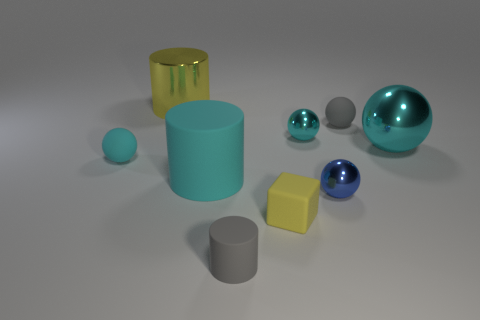Subtract all small gray matte balls. How many balls are left? 4 Subtract all cyan spheres. How many were subtracted if there are1cyan spheres left? 2 Subtract all cyan spheres. How many spheres are left? 2 Subtract 1 cylinders. How many cylinders are left? 2 Subtract all spheres. How many objects are left? 4 Subtract all cyan cylinders. Subtract all green spheres. How many cylinders are left? 2 Subtract all gray cubes. How many brown cylinders are left? 0 Subtract all large balls. Subtract all tiny gray cylinders. How many objects are left? 7 Add 4 large yellow things. How many large yellow things are left? 5 Add 6 cyan metal things. How many cyan metal things exist? 8 